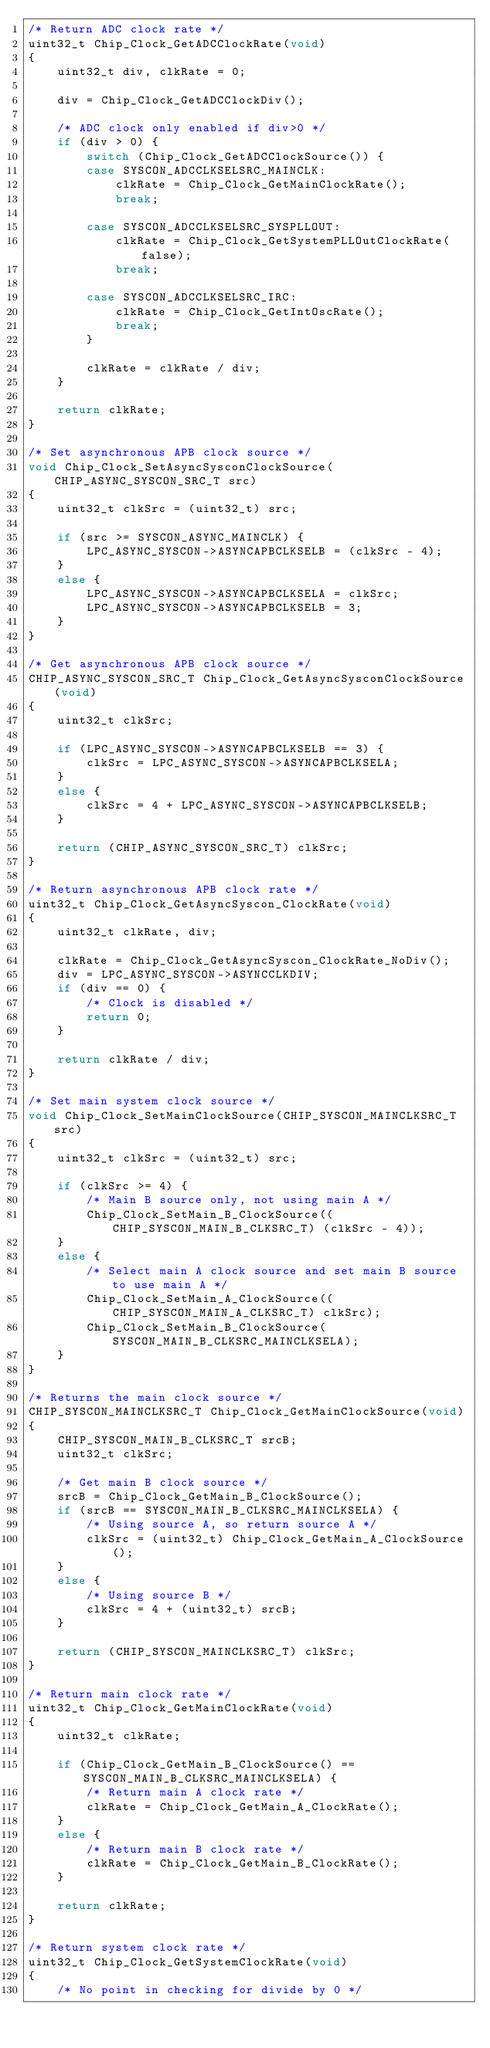Convert code to text. <code><loc_0><loc_0><loc_500><loc_500><_C_>/* Return ADC clock rate */
uint32_t Chip_Clock_GetADCClockRate(void)
{
	uint32_t div, clkRate = 0;

	div = Chip_Clock_GetADCClockDiv();

	/* ADC clock only enabled if div>0 */
	if (div > 0) {
		switch (Chip_Clock_GetADCClockSource()) {
		case SYSCON_ADCCLKSELSRC_MAINCLK:
			clkRate = Chip_Clock_GetMainClockRate();
			break;

		case SYSCON_ADCCLKSELSRC_SYSPLLOUT:
			clkRate = Chip_Clock_GetSystemPLLOutClockRate(false);
			break;

		case SYSCON_ADCCLKSELSRC_IRC:
			clkRate = Chip_Clock_GetIntOscRate();
			break;
		}

		clkRate = clkRate / div;
	}

	return clkRate;
}

/* Set asynchronous APB clock source */
void Chip_Clock_SetAsyncSysconClockSource(CHIP_ASYNC_SYSCON_SRC_T src)
{
	uint32_t clkSrc = (uint32_t) src;

	if (src >= SYSCON_ASYNC_MAINCLK) {
		LPC_ASYNC_SYSCON->ASYNCAPBCLKSELB = (clkSrc - 4);
	}
	else {
		LPC_ASYNC_SYSCON->ASYNCAPBCLKSELA = clkSrc;
		LPC_ASYNC_SYSCON->ASYNCAPBCLKSELB = 3;
	}
}

/* Get asynchronous APB clock source */
CHIP_ASYNC_SYSCON_SRC_T Chip_Clock_GetAsyncSysconClockSource(void)
{
	uint32_t clkSrc;

	if (LPC_ASYNC_SYSCON->ASYNCAPBCLKSELB == 3) {
		clkSrc = LPC_ASYNC_SYSCON->ASYNCAPBCLKSELA;
	}
	else {
		clkSrc = 4 + LPC_ASYNC_SYSCON->ASYNCAPBCLKSELB;
	}

	return (CHIP_ASYNC_SYSCON_SRC_T) clkSrc;
}

/* Return asynchronous APB clock rate */
uint32_t Chip_Clock_GetAsyncSyscon_ClockRate(void)
{
	uint32_t clkRate, div;

	clkRate = Chip_Clock_GetAsyncSyscon_ClockRate_NoDiv();
	div = LPC_ASYNC_SYSCON->ASYNCCLKDIV;
	if (div == 0) {
		/* Clock is disabled */
		return 0;
	}

	return clkRate / div;
}

/* Set main system clock source */
void Chip_Clock_SetMainClockSource(CHIP_SYSCON_MAINCLKSRC_T src)
{
	uint32_t clkSrc = (uint32_t) src;

	if (clkSrc >= 4) {
		/* Main B source only, not using main A */
		Chip_Clock_SetMain_B_ClockSource((CHIP_SYSCON_MAIN_B_CLKSRC_T) (clkSrc - 4));
	}
	else {
		/* Select main A clock source and set main B source to use main A */
		Chip_Clock_SetMain_A_ClockSource((CHIP_SYSCON_MAIN_A_CLKSRC_T) clkSrc);
		Chip_Clock_SetMain_B_ClockSource(SYSCON_MAIN_B_CLKSRC_MAINCLKSELA);
	}
}

/* Returns the main clock source */
CHIP_SYSCON_MAINCLKSRC_T Chip_Clock_GetMainClockSource(void)
{
	CHIP_SYSCON_MAIN_B_CLKSRC_T srcB;
	uint32_t clkSrc;

	/* Get main B clock source */
	srcB = Chip_Clock_GetMain_B_ClockSource();
	if (srcB == SYSCON_MAIN_B_CLKSRC_MAINCLKSELA) {
		/* Using source A, so return source A */
		clkSrc = (uint32_t) Chip_Clock_GetMain_A_ClockSource();
	}
	else {
		/* Using source B */
		clkSrc = 4 + (uint32_t) srcB;
	}

	return (CHIP_SYSCON_MAINCLKSRC_T) clkSrc;
}

/* Return main clock rate */
uint32_t Chip_Clock_GetMainClockRate(void)
{
	uint32_t clkRate;

	if (Chip_Clock_GetMain_B_ClockSource() == SYSCON_MAIN_B_CLKSRC_MAINCLKSELA) {
		/* Return main A clock rate */
		clkRate = Chip_Clock_GetMain_A_ClockRate();
	}
	else {
		/* Return main B clock rate */
		clkRate = Chip_Clock_GetMain_B_ClockRate();
	}

	return clkRate;
}

/* Return system clock rate */
uint32_t Chip_Clock_GetSystemClockRate(void)
{
	/* No point in checking for divide by 0 */</code> 